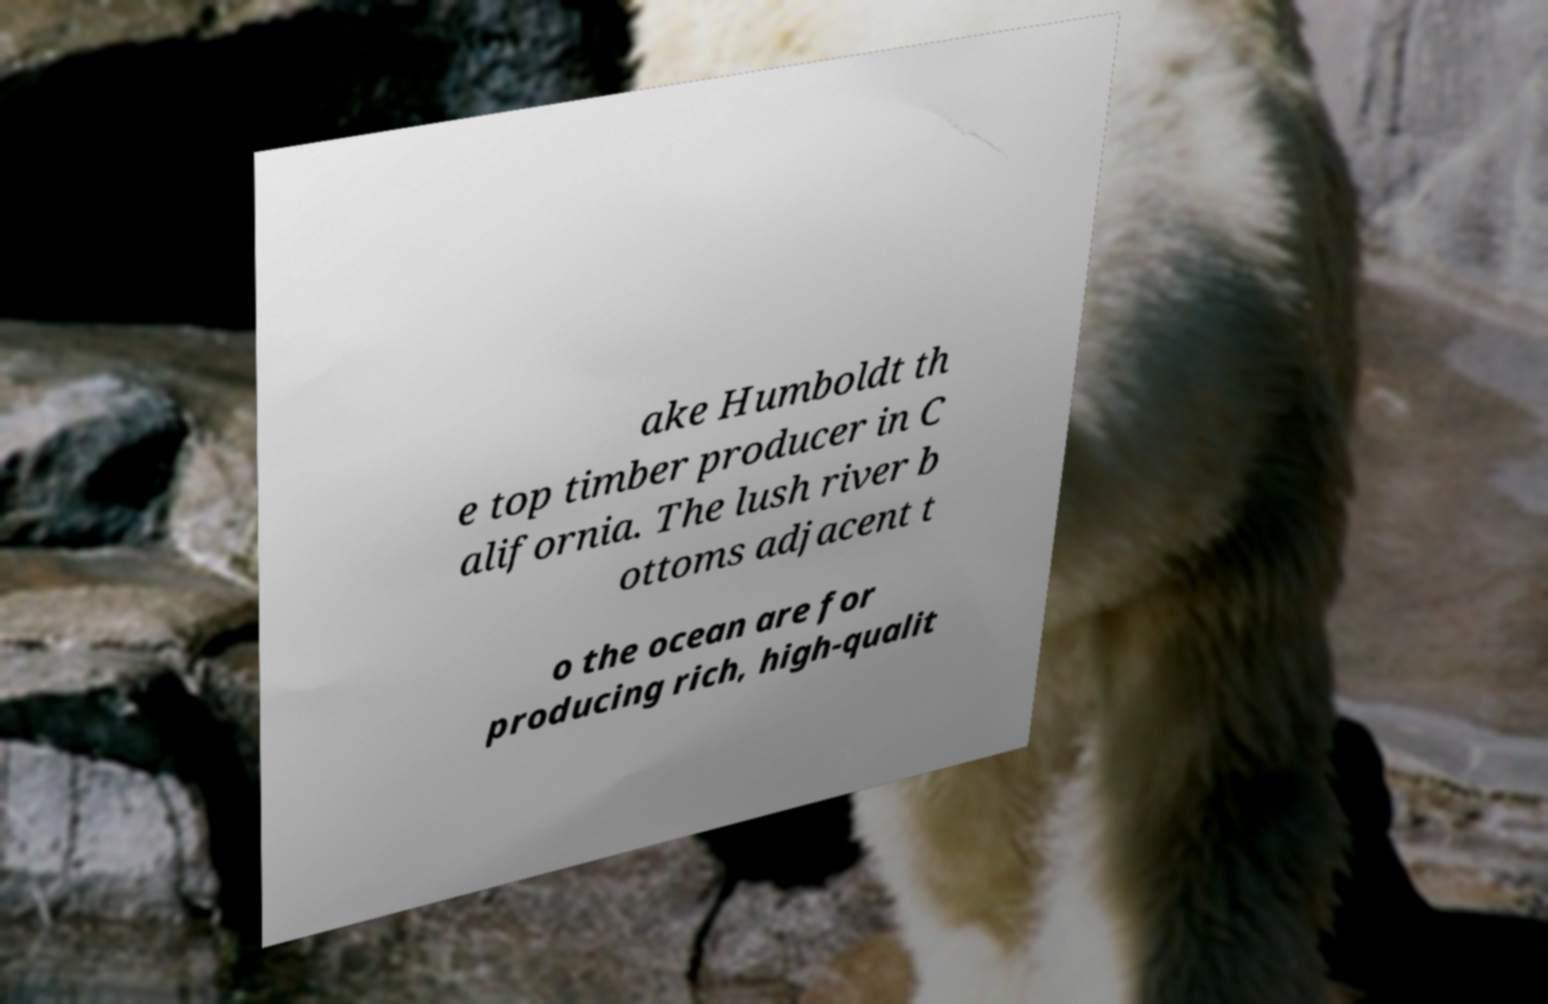Can you accurately transcribe the text from the provided image for me? ake Humboldt th e top timber producer in C alifornia. The lush river b ottoms adjacent t o the ocean are for producing rich, high-qualit 